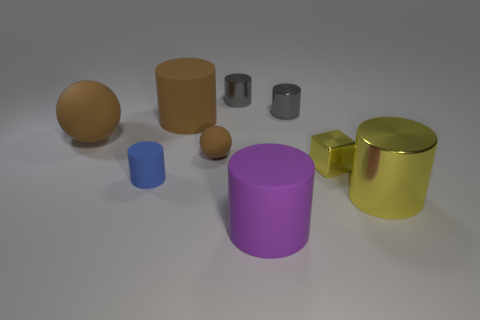Subtract all blue rubber cylinders. How many cylinders are left? 5 Subtract 5 cylinders. How many cylinders are left? 1 Subtract all purple cylinders. How many cylinders are left? 5 Subtract all cylinders. How many objects are left? 3 Subtract 1 yellow cubes. How many objects are left? 8 Subtract all purple cylinders. Subtract all blue cubes. How many cylinders are left? 5 Subtract all red balls. How many brown blocks are left? 0 Subtract all small blue rubber cylinders. Subtract all shiny cylinders. How many objects are left? 5 Add 6 blue things. How many blue things are left? 7 Add 3 tiny metallic blocks. How many tiny metallic blocks exist? 4 